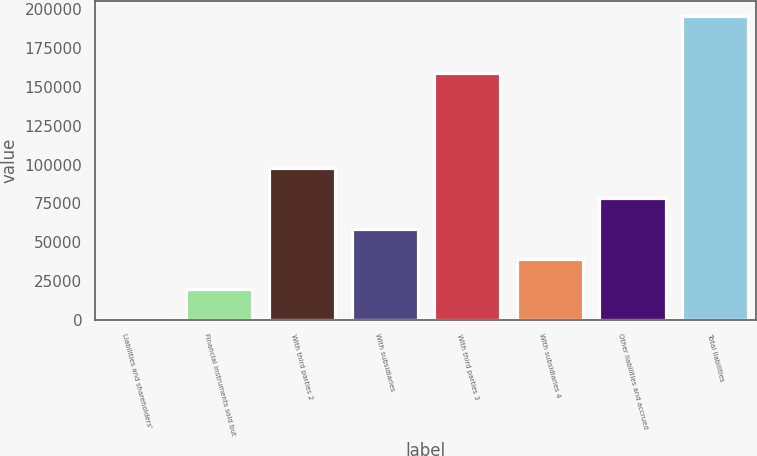Convert chart. <chart><loc_0><loc_0><loc_500><loc_500><bar_chart><fcel>Liabilities and shareholders'<fcel>Financial instruments sold but<fcel>With third parties 2<fcel>With subsidiaries<fcel>With third parties 3<fcel>With subsidiaries 4<fcel>Other liabilities and accrued<fcel>Total liabilities<nl><fcel>129<fcel>19689.4<fcel>97931<fcel>58810.2<fcel>158613<fcel>39249.8<fcel>78370.6<fcel>195733<nl></chart> 